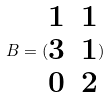Convert formula to latex. <formula><loc_0><loc_0><loc_500><loc_500>B = ( \begin{matrix} 1 & 1 \\ 3 & 1 \\ 0 & 2 \end{matrix} )</formula> 